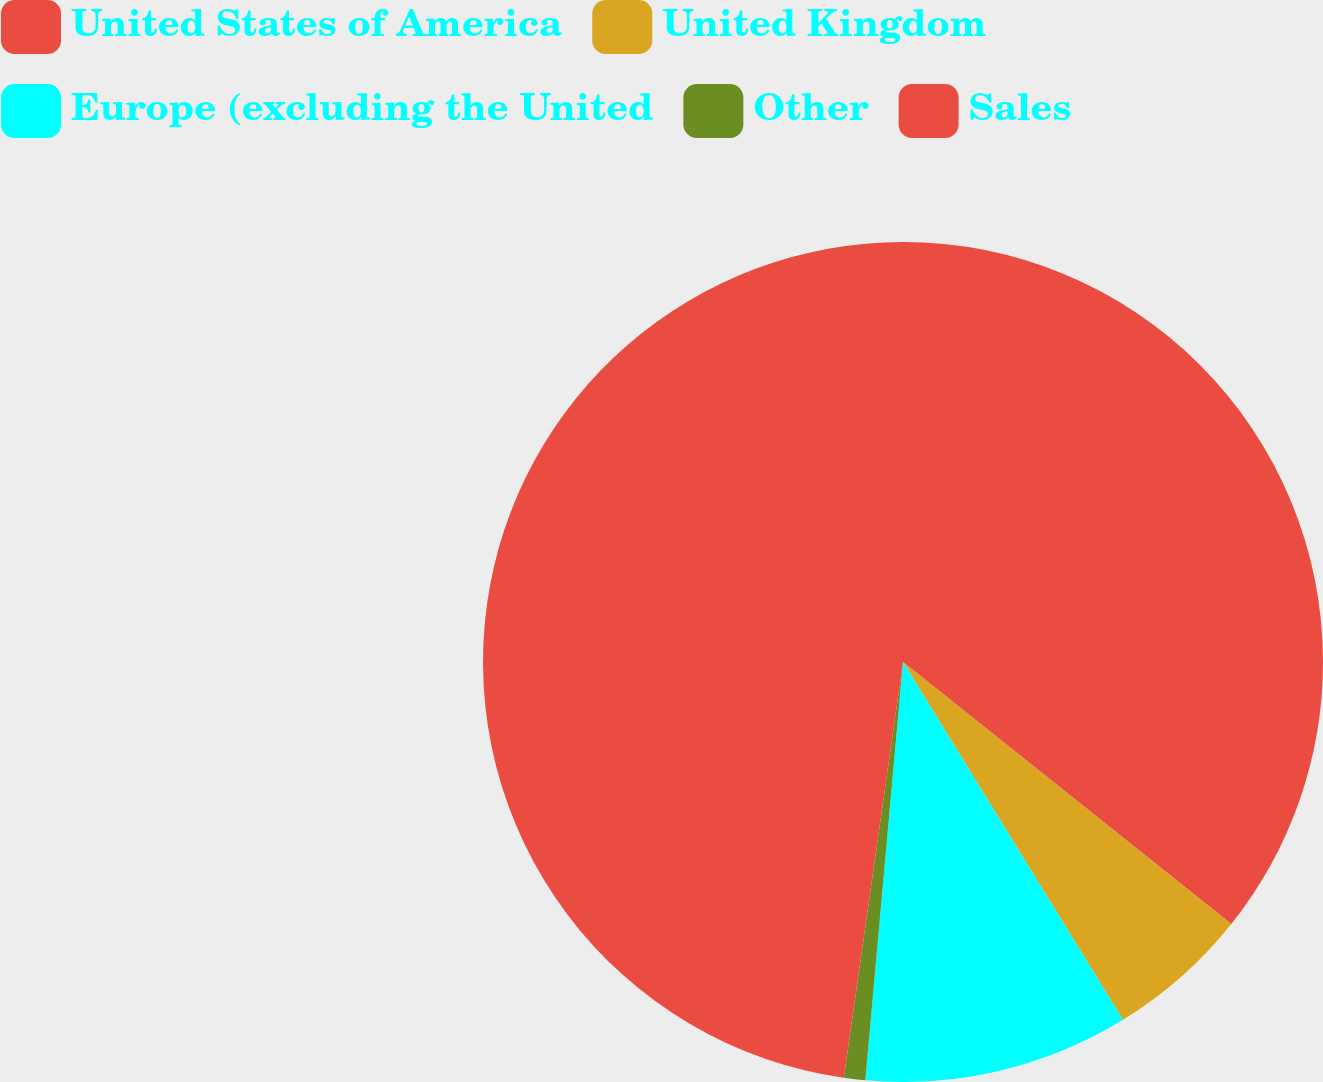Convert chart. <chart><loc_0><loc_0><loc_500><loc_500><pie_chart><fcel>United States of America<fcel>United Kingdom<fcel>Europe (excluding the United<fcel>Other<fcel>Sales<nl><fcel>35.72%<fcel>5.51%<fcel>10.2%<fcel>0.82%<fcel>47.75%<nl></chart> 